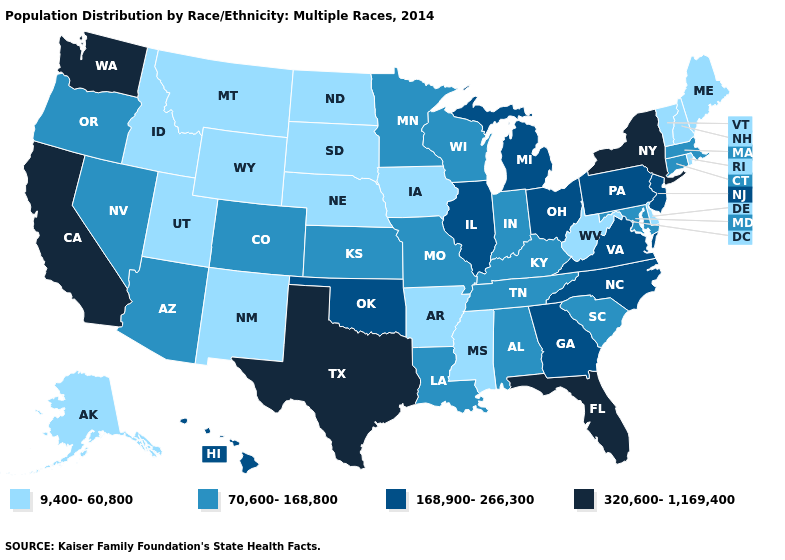Among the states that border Colorado , does Oklahoma have the highest value?
Keep it brief. Yes. Name the states that have a value in the range 70,600-168,800?
Be succinct. Alabama, Arizona, Colorado, Connecticut, Indiana, Kansas, Kentucky, Louisiana, Maryland, Massachusetts, Minnesota, Missouri, Nevada, Oregon, South Carolina, Tennessee, Wisconsin. Among the states that border South Dakota , does Minnesota have the highest value?
Keep it brief. Yes. Does Massachusetts have the lowest value in the Northeast?
Answer briefly. No. Does Mississippi have the highest value in the USA?
Write a very short answer. No. Name the states that have a value in the range 168,900-266,300?
Quick response, please. Georgia, Hawaii, Illinois, Michigan, New Jersey, North Carolina, Ohio, Oklahoma, Pennsylvania, Virginia. Is the legend a continuous bar?
Concise answer only. No. What is the value of Delaware?
Keep it brief. 9,400-60,800. What is the value of Montana?
Quick response, please. 9,400-60,800. Name the states that have a value in the range 70,600-168,800?
Short answer required. Alabama, Arizona, Colorado, Connecticut, Indiana, Kansas, Kentucky, Louisiana, Maryland, Massachusetts, Minnesota, Missouri, Nevada, Oregon, South Carolina, Tennessee, Wisconsin. Does Idaho have the highest value in the USA?
Short answer required. No. Does Arizona have a higher value than Iowa?
Answer briefly. Yes. Does Rhode Island have the lowest value in the Northeast?
Concise answer only. Yes. What is the value of Nebraska?
Give a very brief answer. 9,400-60,800. Name the states that have a value in the range 168,900-266,300?
Short answer required. Georgia, Hawaii, Illinois, Michigan, New Jersey, North Carolina, Ohio, Oklahoma, Pennsylvania, Virginia. 